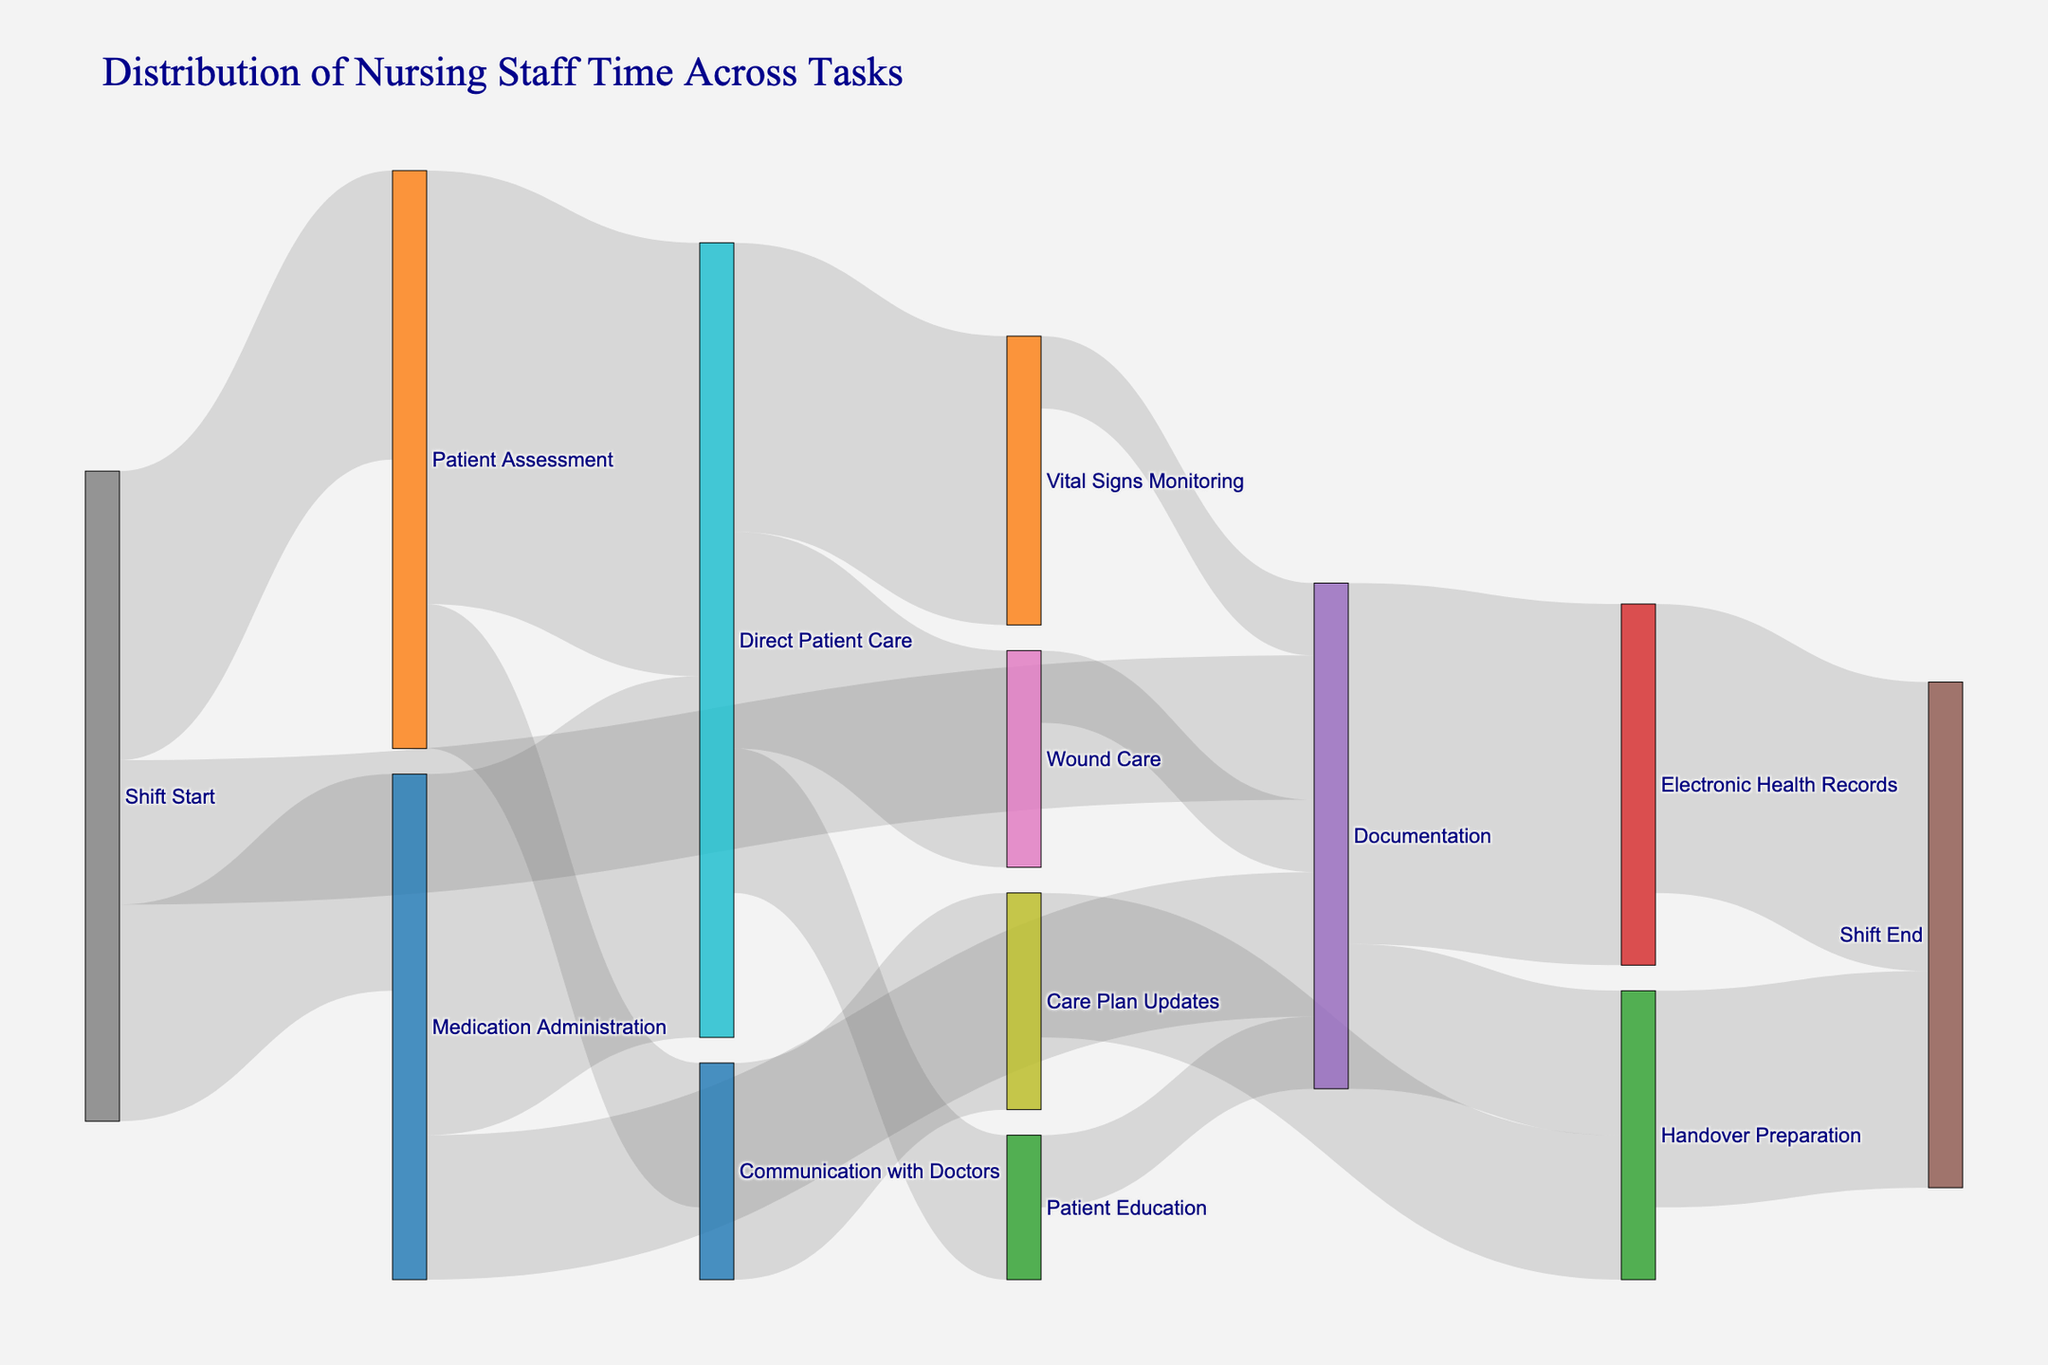What is the title of the figure? The title is usually located at the top of the figure, providing a summary of the data shown. In this case, it summarizes the distribution of nursing staff time.
Answer: Distribution of Nursing Staff Time Across Tasks How much time is spent on Patient Assessment at the start of the shift? To find this, look at the link connecting "Shift Start" to "Patient Assessment," which shows the value representing the amount of time spent.
Answer: 20 units Which task receives more time: Direct Patient Care or Documentation? To determine this, sum the values flowing into both tasks and compare them. Direct Patient Care receives 30 from Patient Assessment and 25 from Medication Administration, totaling 55. Documentation receives 10 from Shift Start and 10 from Medication Administration, totaling 20.
Answer: Direct Patient Care How much time is spent on Handover Preparation before the shift ends? Find the link that connects "Handover Preparation" to "Shift End" to get the time allocated to Handover Preparation.
Answer: 15 units Which task under Direct Patient Care has the least amount of time allocated and how much time is it? Look at the links from "Direct Patient Care" to its subtasks. "Patient Education" has 10 units, which is the least compared to Wound Care (15) and Vital Signs Monitoring (20).
Answer: Patient Education, 10 units What is the total amount of time spent on Documentation throughout the shift? Sum the time allocated to all tasks under Documentation from start to finish. This includes 10 from Shift Start, 10 from Medication Administration, 25 from Electronic Health Records, 5 from Wound Care, 5 from Vital Signs Monitoring, and 5 from Patient Education.
Answer: 60 units Compare the amount of time spent on Medication Administration at the start of the shift versus the end. Only need to consider the time at the start of the shift since no Medication Administration task is directly shown at the end. The value from shift start is 15 units.
Answer: 15 units What is the total amount of time spent on tasks directly related to patient care activities (including Direct Patient Care and its subtasks)? Sum the values from Patient Assessment to Direct Patient Care (30) and Medication Administration to Direct Patient Care (25), plus Wound Care (15), Vital Signs Monitoring (20), and Patient Education (10).
Answer: 100 units How much time is spent on Care Plan Updates throughout the shift? Add the time allocated to Care Plan Updates, which is 10 from Communication with Doctors and 10 for Handover Preparation.
Answer: 20 units What is the primary task nurses spend time on after communicating with doctors? Identify the main task by looking at the link directly following Communication with Doctors.
Answer: Care Plan Updates 